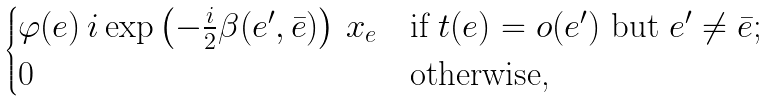<formula> <loc_0><loc_0><loc_500><loc_500>\begin{cases} \varphi ( e ) \, i \exp \left ( - \frac { i } { 2 } \beta ( e ^ { \prime } , \bar { e } ) \right ) \, x _ { e } & \text {if $t(e)=o(e^{\prime})$ but $e^{\prime}\neq \bar{e}$;} \\ 0 & \text {otherwise,} \end{cases}</formula> 